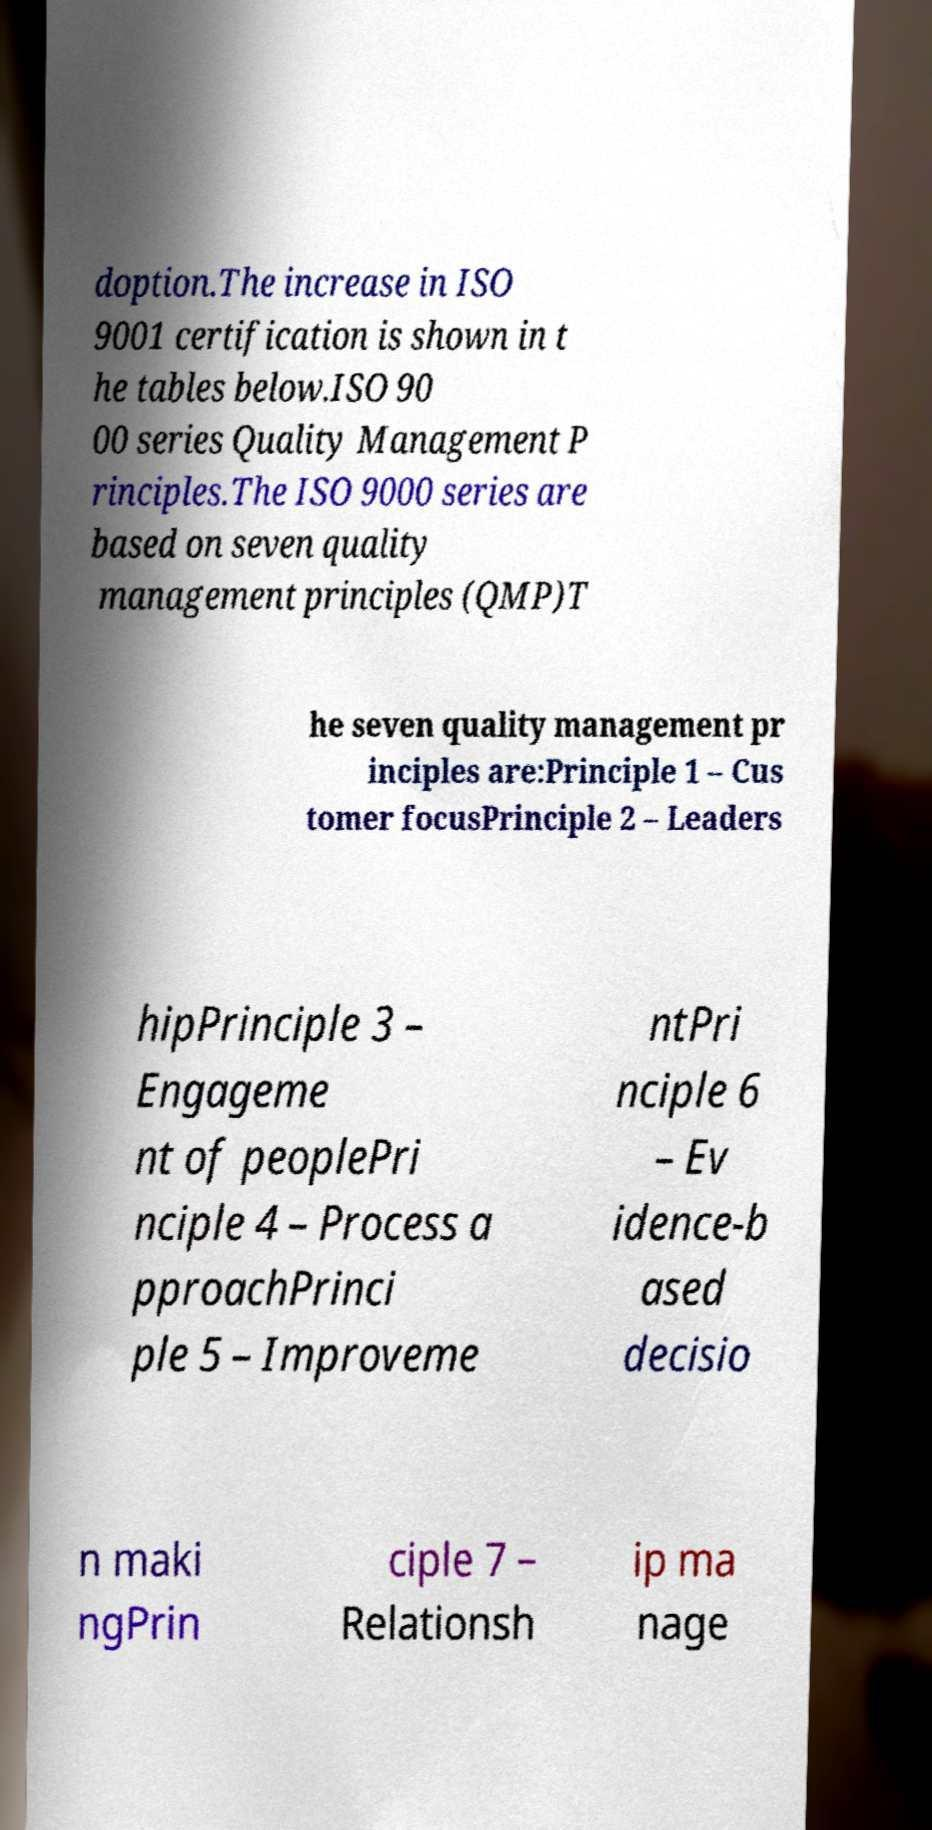I need the written content from this picture converted into text. Can you do that? doption.The increase in ISO 9001 certification is shown in t he tables below.ISO 90 00 series Quality Management P rinciples.The ISO 9000 series are based on seven quality management principles (QMP)T he seven quality management pr inciples are:Principle 1 – Cus tomer focusPrinciple 2 – Leaders hipPrinciple 3 – Engageme nt of peoplePri nciple 4 – Process a pproachPrinci ple 5 – Improveme ntPri nciple 6 – Ev idence-b ased decisio n maki ngPrin ciple 7 – Relationsh ip ma nage 